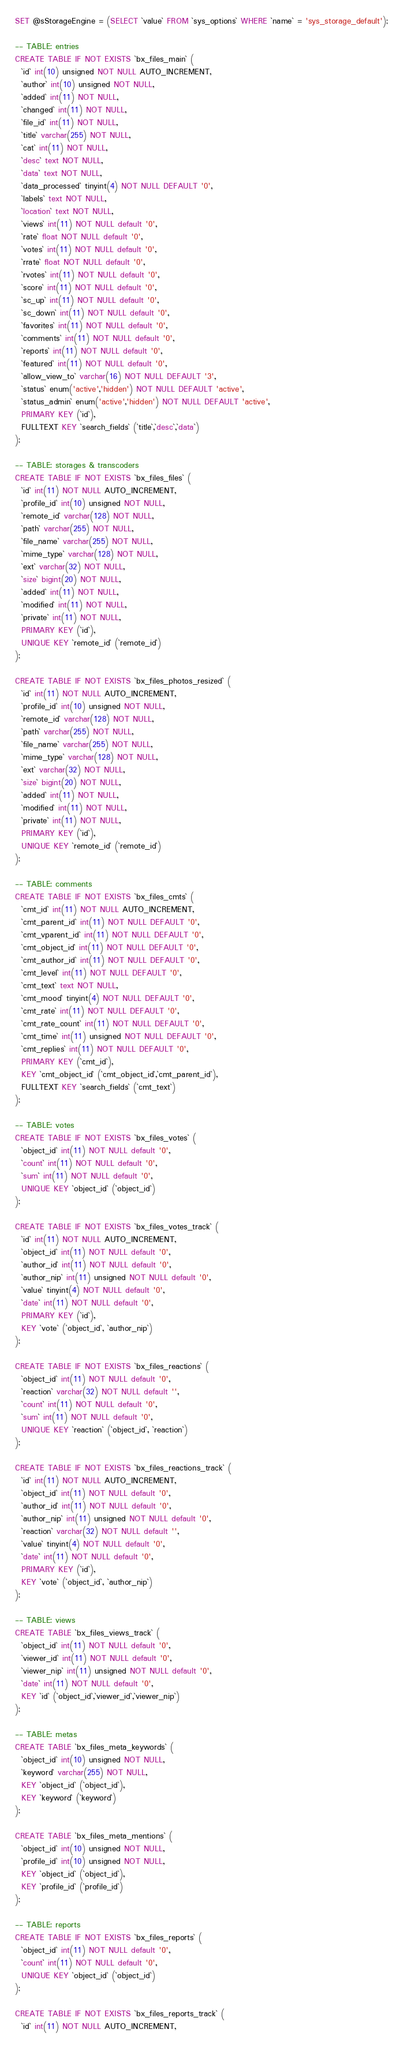Convert code to text. <code><loc_0><loc_0><loc_500><loc_500><_SQL_>
SET @sStorageEngine = (SELECT `value` FROM `sys_options` WHERE `name` = 'sys_storage_default');

-- TABLE: entries
CREATE TABLE IF NOT EXISTS `bx_files_main` (
  `id` int(10) unsigned NOT NULL AUTO_INCREMENT,
  `author` int(10) unsigned NOT NULL,
  `added` int(11) NOT NULL,
  `changed` int(11) NOT NULL,
  `file_id` int(11) NOT NULL,
  `title` varchar(255) NOT NULL,
  `cat` int(11) NOT NULL,
  `desc` text NOT NULL,
  `data` text NOT NULL,
  `data_processed` tinyint(4) NOT NULL DEFAULT '0',
  `labels` text NOT NULL,
  `location` text NOT NULL,
  `views` int(11) NOT NULL default '0',
  `rate` float NOT NULL default '0',
  `votes` int(11) NOT NULL default '0',
  `rrate` float NOT NULL default '0',
  `rvotes` int(11) NOT NULL default '0',
  `score` int(11) NOT NULL default '0',
  `sc_up` int(11) NOT NULL default '0',
  `sc_down` int(11) NOT NULL default '0',
  `favorites` int(11) NOT NULL default '0',
  `comments` int(11) NOT NULL default '0',
  `reports` int(11) NOT NULL default '0',
  `featured` int(11) NOT NULL default '0',
  `allow_view_to` varchar(16) NOT NULL DEFAULT '3',
  `status` enum('active','hidden') NOT NULL DEFAULT 'active',
  `status_admin` enum('active','hidden') NOT NULL DEFAULT 'active',
  PRIMARY KEY (`id`),
  FULLTEXT KEY `search_fields` (`title`,`desc`,`data`)
);

-- TABLE: storages & transcoders
CREATE TABLE IF NOT EXISTS `bx_files_files` (
  `id` int(11) NOT NULL AUTO_INCREMENT,
  `profile_id` int(10) unsigned NOT NULL,
  `remote_id` varchar(128) NOT NULL,
  `path` varchar(255) NOT NULL,
  `file_name` varchar(255) NOT NULL,
  `mime_type` varchar(128) NOT NULL,
  `ext` varchar(32) NOT NULL,
  `size` bigint(20) NOT NULL,
  `added` int(11) NOT NULL,
  `modified` int(11) NOT NULL,
  `private` int(11) NOT NULL,
  PRIMARY KEY (`id`),
  UNIQUE KEY `remote_id` (`remote_id`)
);

CREATE TABLE IF NOT EXISTS `bx_files_photos_resized` (
  `id` int(11) NOT NULL AUTO_INCREMENT,
  `profile_id` int(10) unsigned NOT NULL,
  `remote_id` varchar(128) NOT NULL,
  `path` varchar(255) NOT NULL,
  `file_name` varchar(255) NOT NULL,
  `mime_type` varchar(128) NOT NULL,
  `ext` varchar(32) NOT NULL,
  `size` bigint(20) NOT NULL,
  `added` int(11) NOT NULL,
  `modified` int(11) NOT NULL,
  `private` int(11) NOT NULL,
  PRIMARY KEY (`id`),
  UNIQUE KEY `remote_id` (`remote_id`)
);

-- TABLE: comments
CREATE TABLE IF NOT EXISTS `bx_files_cmts` (
  `cmt_id` int(11) NOT NULL AUTO_INCREMENT,
  `cmt_parent_id` int(11) NOT NULL DEFAULT '0',
  `cmt_vparent_id` int(11) NOT NULL DEFAULT '0',
  `cmt_object_id` int(11) NOT NULL DEFAULT '0',
  `cmt_author_id` int(11) NOT NULL DEFAULT '0',
  `cmt_level` int(11) NOT NULL DEFAULT '0',
  `cmt_text` text NOT NULL,
  `cmt_mood` tinyint(4) NOT NULL DEFAULT '0',
  `cmt_rate` int(11) NOT NULL DEFAULT '0',
  `cmt_rate_count` int(11) NOT NULL DEFAULT '0',
  `cmt_time` int(11) unsigned NOT NULL DEFAULT '0',
  `cmt_replies` int(11) NOT NULL DEFAULT '0',
  PRIMARY KEY (`cmt_id`),
  KEY `cmt_object_id` (`cmt_object_id`,`cmt_parent_id`),
  FULLTEXT KEY `search_fields` (`cmt_text`)
);

-- TABLE: votes
CREATE TABLE IF NOT EXISTS `bx_files_votes` (
  `object_id` int(11) NOT NULL default '0',
  `count` int(11) NOT NULL default '0',
  `sum` int(11) NOT NULL default '0',
  UNIQUE KEY `object_id` (`object_id`)
);

CREATE TABLE IF NOT EXISTS `bx_files_votes_track` (
  `id` int(11) NOT NULL AUTO_INCREMENT,
  `object_id` int(11) NOT NULL default '0',
  `author_id` int(11) NOT NULL default '0',
  `author_nip` int(11) unsigned NOT NULL default '0',
  `value` tinyint(4) NOT NULL default '0',
  `date` int(11) NOT NULL default '0',
  PRIMARY KEY (`id`),
  KEY `vote` (`object_id`, `author_nip`)
);

CREATE TABLE IF NOT EXISTS `bx_files_reactions` (
  `object_id` int(11) NOT NULL default '0',
  `reaction` varchar(32) NOT NULL default '',
  `count` int(11) NOT NULL default '0',
  `sum` int(11) NOT NULL default '0',
  UNIQUE KEY `reaction` (`object_id`, `reaction`)
);

CREATE TABLE IF NOT EXISTS `bx_files_reactions_track` (
  `id` int(11) NOT NULL AUTO_INCREMENT,
  `object_id` int(11) NOT NULL default '0',
  `author_id` int(11) NOT NULL default '0',
  `author_nip` int(11) unsigned NOT NULL default '0',
  `reaction` varchar(32) NOT NULL default '',
  `value` tinyint(4) NOT NULL default '0',
  `date` int(11) NOT NULL default '0',
  PRIMARY KEY (`id`),
  KEY `vote` (`object_id`, `author_nip`)
);

-- TABLE: views
CREATE TABLE `bx_files_views_track` (
  `object_id` int(11) NOT NULL default '0',
  `viewer_id` int(11) NOT NULL default '0',
  `viewer_nip` int(11) unsigned NOT NULL default '0',
  `date` int(11) NOT NULL default '0',
  KEY `id` (`object_id`,`viewer_id`,`viewer_nip`)
);

-- TABLE: metas
CREATE TABLE `bx_files_meta_keywords` (
  `object_id` int(10) unsigned NOT NULL,
  `keyword` varchar(255) NOT NULL,
  KEY `object_id` (`object_id`),
  KEY `keyword` (`keyword`)
);

CREATE TABLE `bx_files_meta_mentions` (
  `object_id` int(10) unsigned NOT NULL,
  `profile_id` int(10) unsigned NOT NULL,
  KEY `object_id` (`object_id`),
  KEY `profile_id` (`profile_id`)
);

-- TABLE: reports
CREATE TABLE IF NOT EXISTS `bx_files_reports` (
  `object_id` int(11) NOT NULL default '0',
  `count` int(11) NOT NULL default '0',
  UNIQUE KEY `object_id` (`object_id`)
);

CREATE TABLE IF NOT EXISTS `bx_files_reports_track` (
  `id` int(11) NOT NULL AUTO_INCREMENT,</code> 